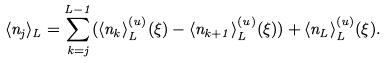<formula> <loc_0><loc_0><loc_500><loc_500>\langle n _ { j } \rangle _ { L } = \sum _ { k = j } ^ { L - 1 } ( \langle n _ { k } \rangle _ { L } ^ { ( u ) } ( \xi ) - \langle n _ { k + 1 } \rangle _ { L } ^ { ( u ) } ( \xi ) ) + \langle n _ { L } \rangle _ { L } ^ { ( u ) } ( \xi ) .</formula> 